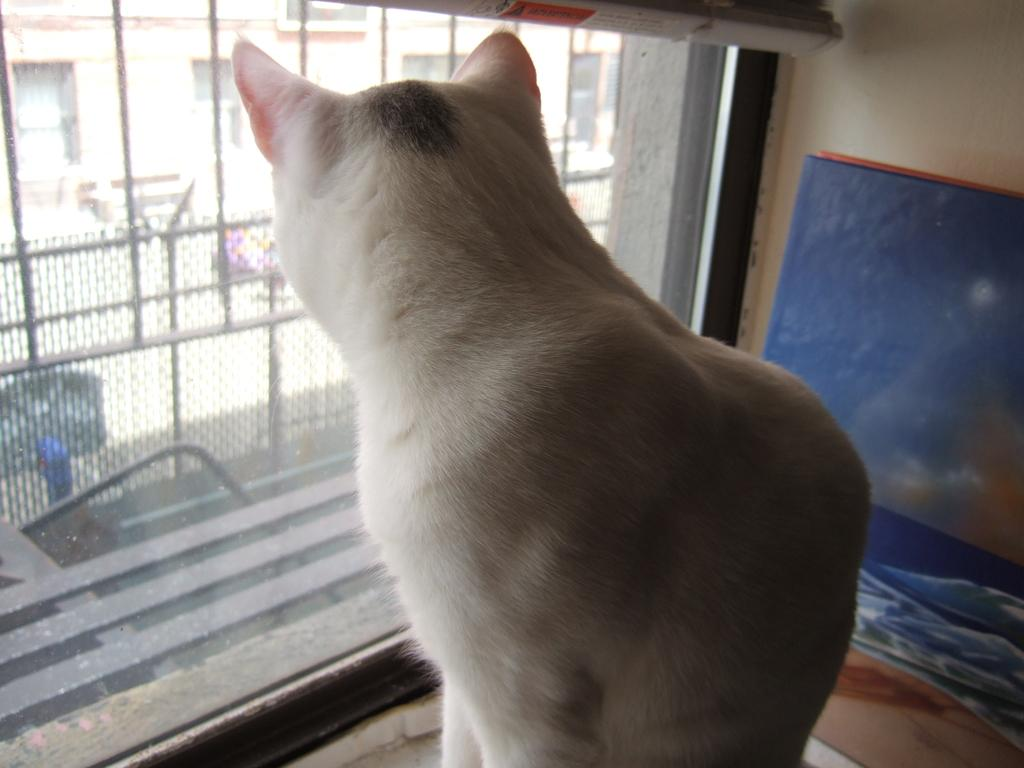What is the main subject in the center of the image? There is a cat in the center of the image. Can you describe the appearance of the cat? The cat is white in color. What can be seen on the left side of the image? There is a window on the left side of the image. What grade does the representative lift in the image? There is no representative or lifting activity present in the image; it features a white cat in the center and a window on the left side. 